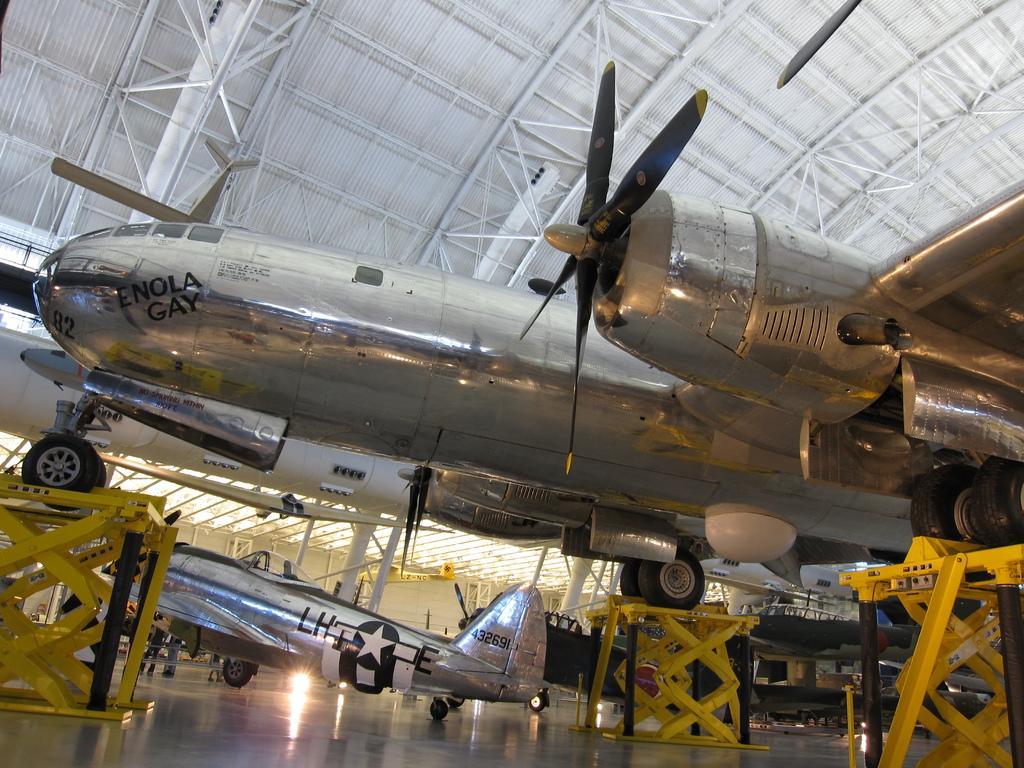Could you give a brief overview of what you see in this image? In this image I can see few aeroplanes on the floor and there are some metal rods in yellow color. 